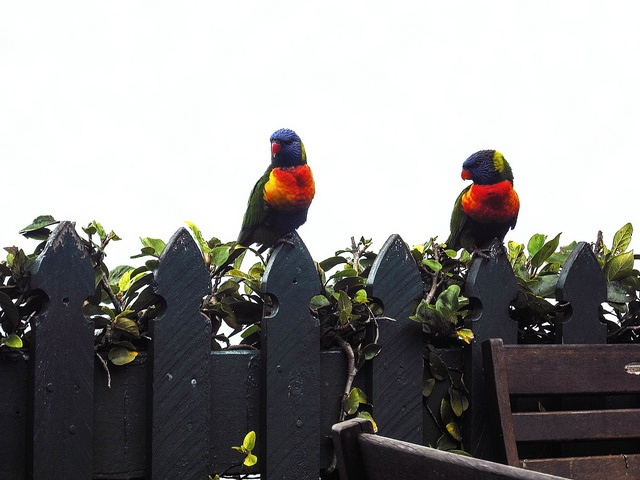Describe the objects in this image and their specific colors. I can see bench in white, black, gray, and maroon tones, chair in white, black, gray, and darkgray tones, bird in white, black, maroon, and brown tones, and bird in white, black, brown, maroon, and red tones in this image. 